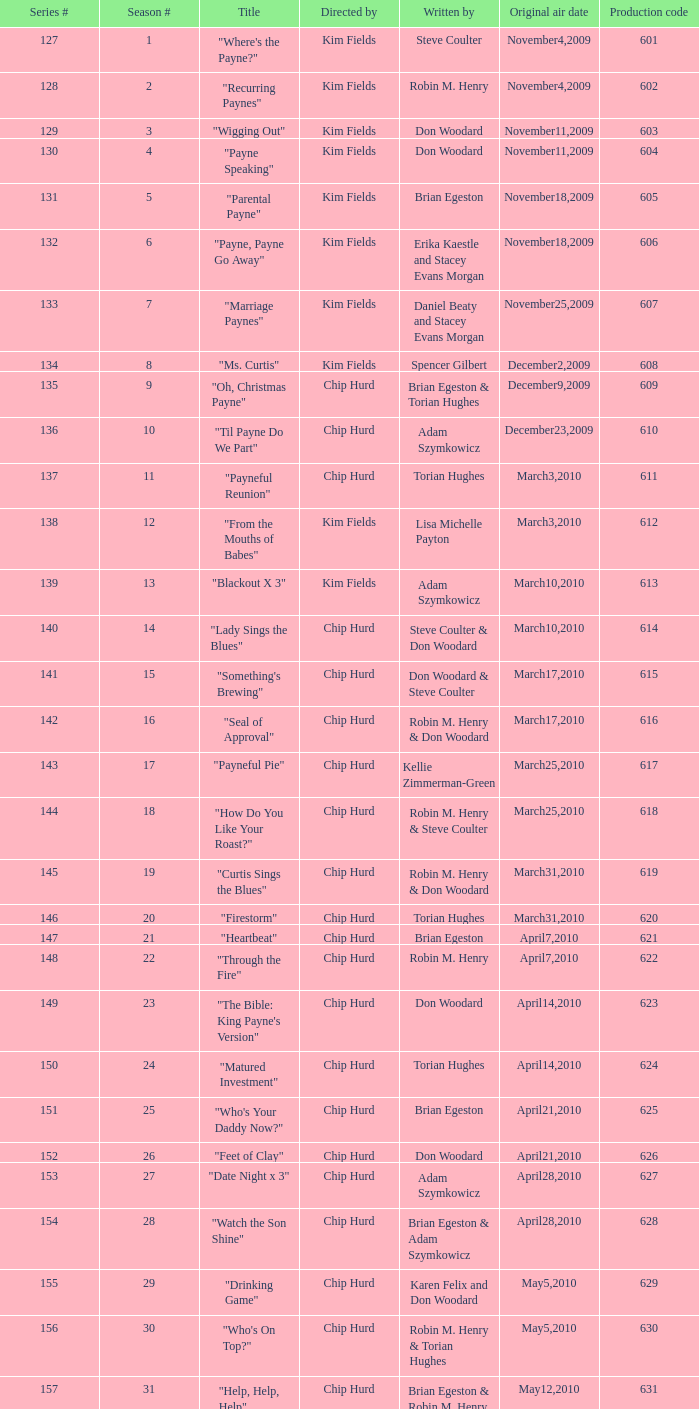What is the title of the episode with the production code 624? "Matured Investment". 